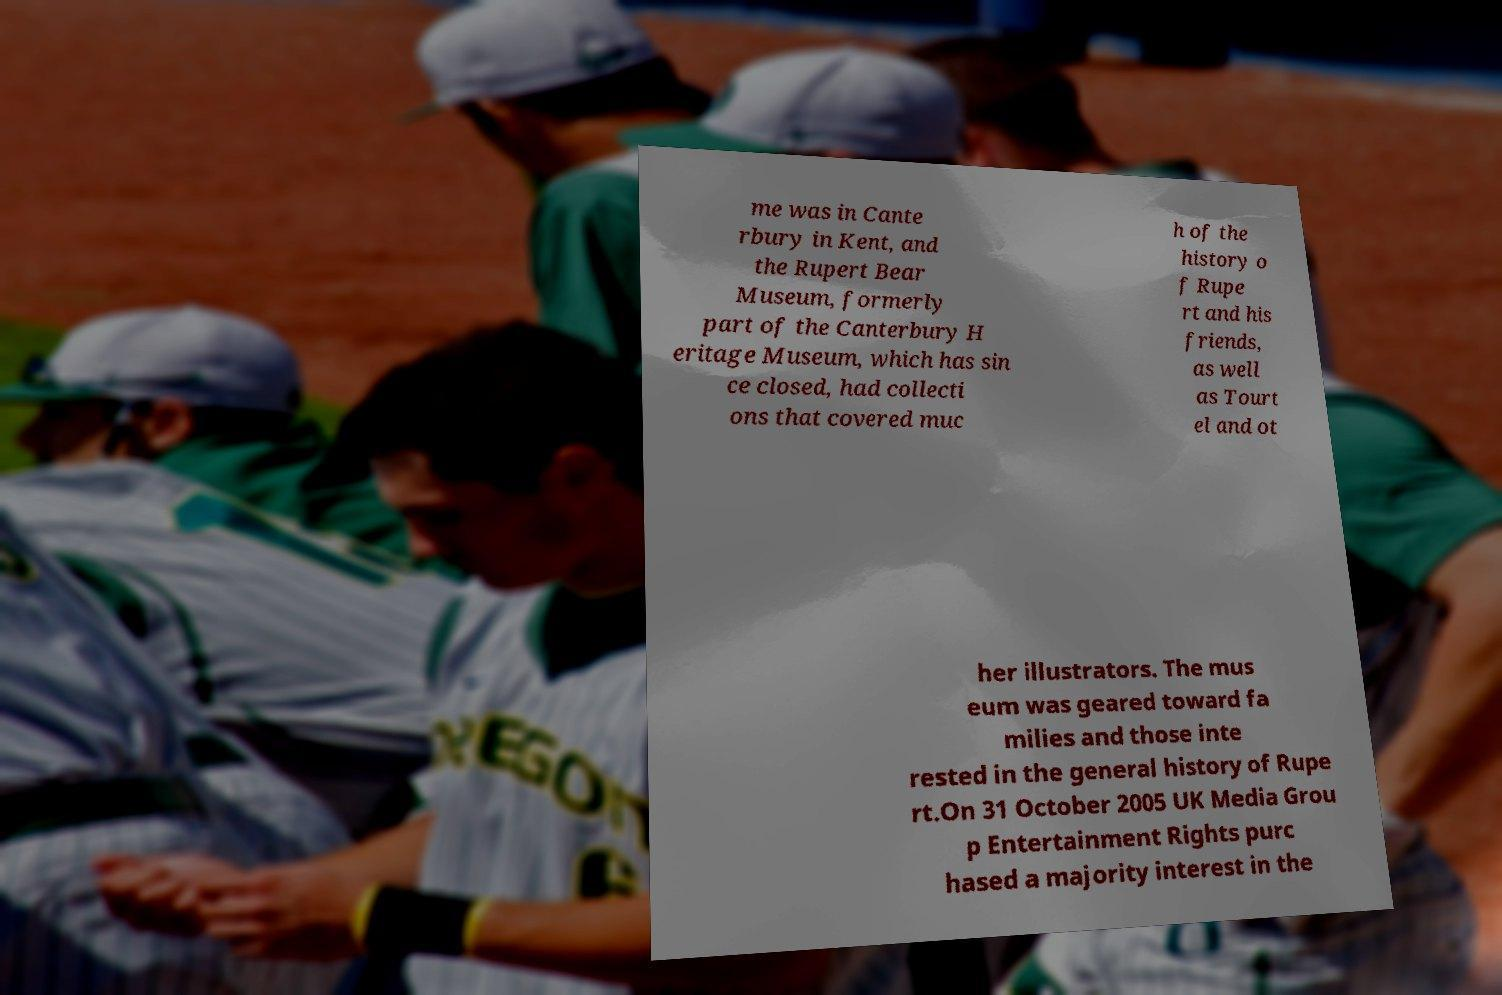Can you accurately transcribe the text from the provided image for me? me was in Cante rbury in Kent, and the Rupert Bear Museum, formerly part of the Canterbury H eritage Museum, which has sin ce closed, had collecti ons that covered muc h of the history o f Rupe rt and his friends, as well as Tourt el and ot her illustrators. The mus eum was geared toward fa milies and those inte rested in the general history of Rupe rt.On 31 October 2005 UK Media Grou p Entertainment Rights purc hased a majority interest in the 